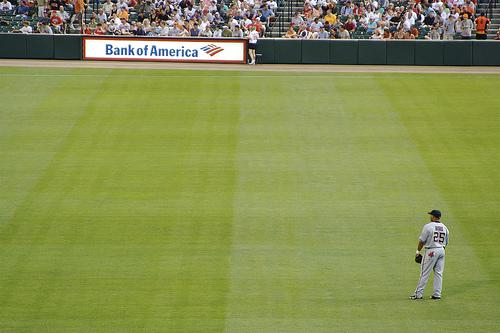Question: where is the picture taking place?
Choices:
A. My house.
B. A stadium.
C. A river.
D. Down the street.
Answer with the letter. Answer: B Question: how many people are there?
Choices:
A. 3.
B. Dozen.
C. Hundreds.
D. None.
Answer with the letter. Answer: C Question: what is the player holding?
Choices:
A. The ball.
B. A baseball mitt.
C. A bat.
D. His crotch.
Answer with the letter. Answer: B Question: why is the player standing still?
Choices:
A. Play is paused.
B. He is frozen.
C. A stroke.
D. He is waiting.
Answer with the letter. Answer: D Question: what is on the player's head?
Choices:
A. A baseball cap.
B. A helmet.
C. Sweatband.
D. A wig.
Answer with the letter. Answer: A 